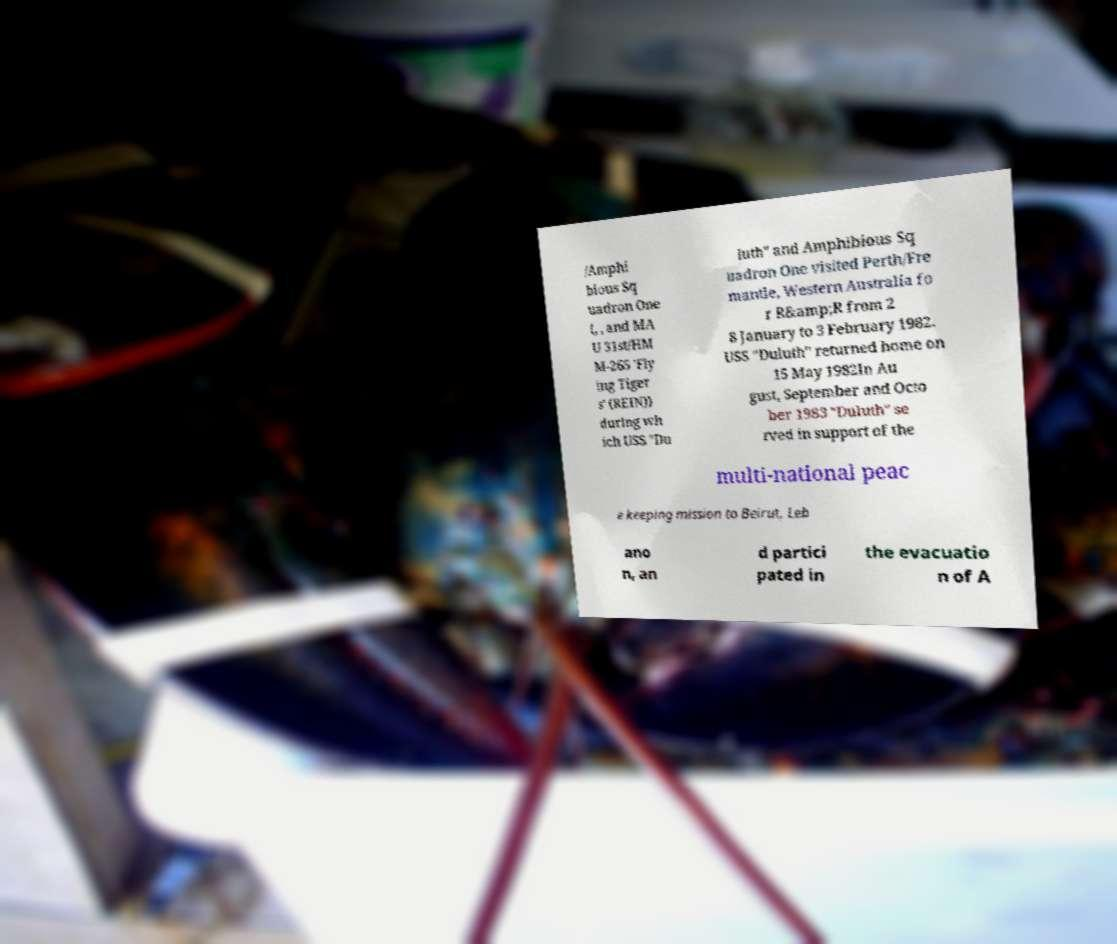Can you read and provide the text displayed in the image?This photo seems to have some interesting text. Can you extract and type it out for me? /Amphi bious Sq uadron One (, , and MA U 31st/HM M-265 'Fly ing Tiger s' (REIN)) during wh ich USS "Du luth" and Amphibious Sq uadron One visited Perth/Fre mantle, Western Australia fo r R&amp;R from 2 8 January to 3 February 1982. USS "Duluth" returned home on 15 May 1982In Au gust, September and Octo ber 1983 "Duluth" se rved in support of the multi-national peac e keeping mission to Beirut, Leb ano n, an d partici pated in the evacuatio n of A 